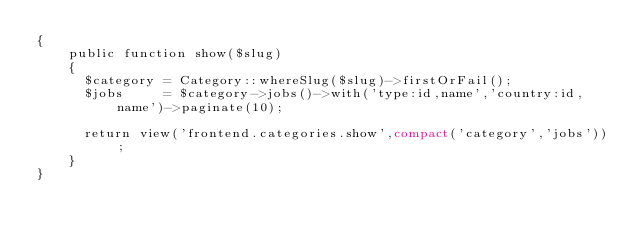Convert code to text. <code><loc_0><loc_0><loc_500><loc_500><_PHP_>{
    public function show($slug)
    {
    	$category = Category::whereSlug($slug)->firstOrFail();
    	$jobs     = $category->jobs()->with('type:id,name','country:id,name')->paginate(10);
    	
    	return view('frontend.categories.show',compact('category','jobs'));
    }
}
</code> 